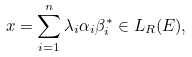Convert formula to latex. <formula><loc_0><loc_0><loc_500><loc_500>x = \sum _ { i = 1 } ^ { n } \lambda _ { i } \alpha _ { i } \beta _ { i } ^ { * } \in L _ { R } ( E ) ,</formula> 